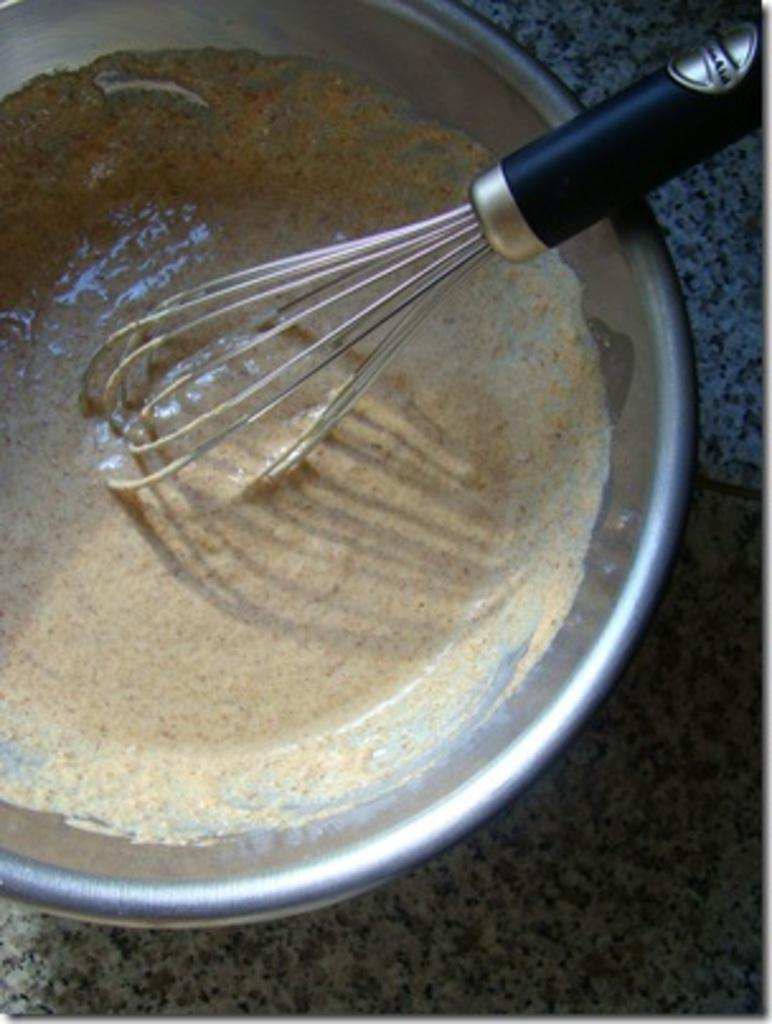What type of food item is in the bowl in the image? The specific type of food item in the bowl is not mentioned, but there is a food item in the bowl. What utensil is present in the image? There is an egg beater in the image. On what surface is the egg beater placed? The egg beater is on a granite surface. Can you see a bear eating honey with a mitten in the image? No, there is no bear, honey, or mitten present in the image. 